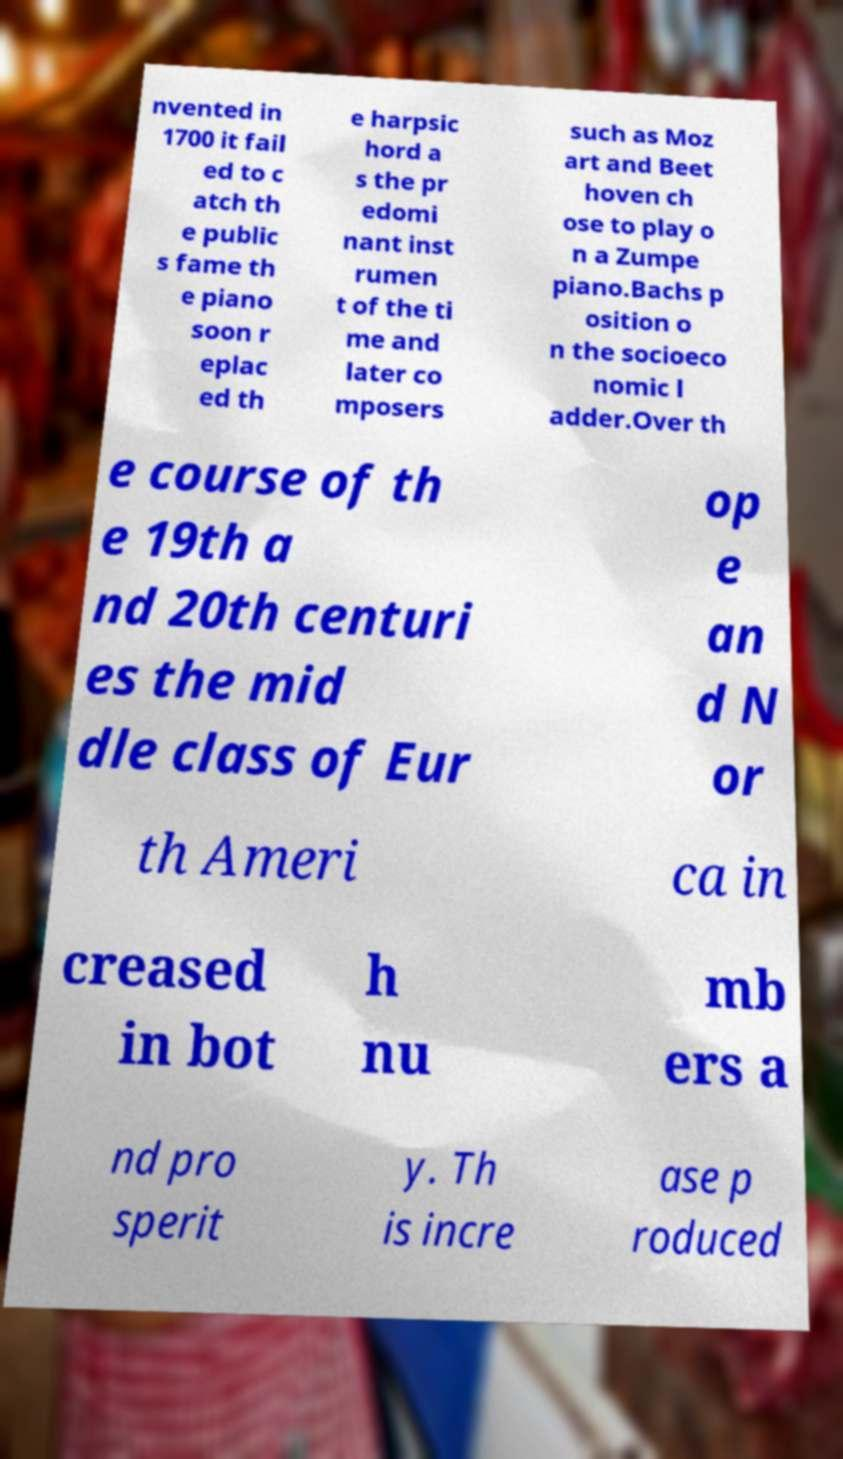Please identify and transcribe the text found in this image. nvented in 1700 it fail ed to c atch th e public s fame th e piano soon r eplac ed th e harpsic hord a s the pr edomi nant inst rumen t of the ti me and later co mposers such as Moz art and Beet hoven ch ose to play o n a Zumpe piano.Bachs p osition o n the socioeco nomic l adder.Over th e course of th e 19th a nd 20th centuri es the mid dle class of Eur op e an d N or th Ameri ca in creased in bot h nu mb ers a nd pro sperit y. Th is incre ase p roduced 